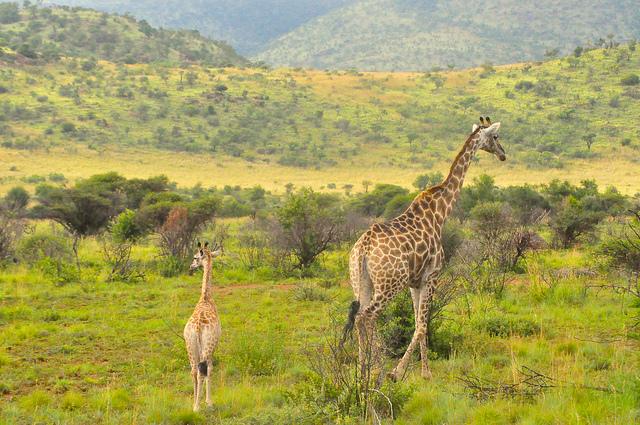Are there any hills?
Answer briefly. Yes. Where was this pic taken?
Concise answer only. Africa. How might you assume these two are related?
Be succinct. Mother and baby. 